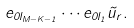<formula> <loc_0><loc_0><loc_500><loc_500>e _ { 0 l _ { M - K - 1 } } \cdots e _ { 0 l _ { 1 } } \tilde { u } _ { r } .</formula> 